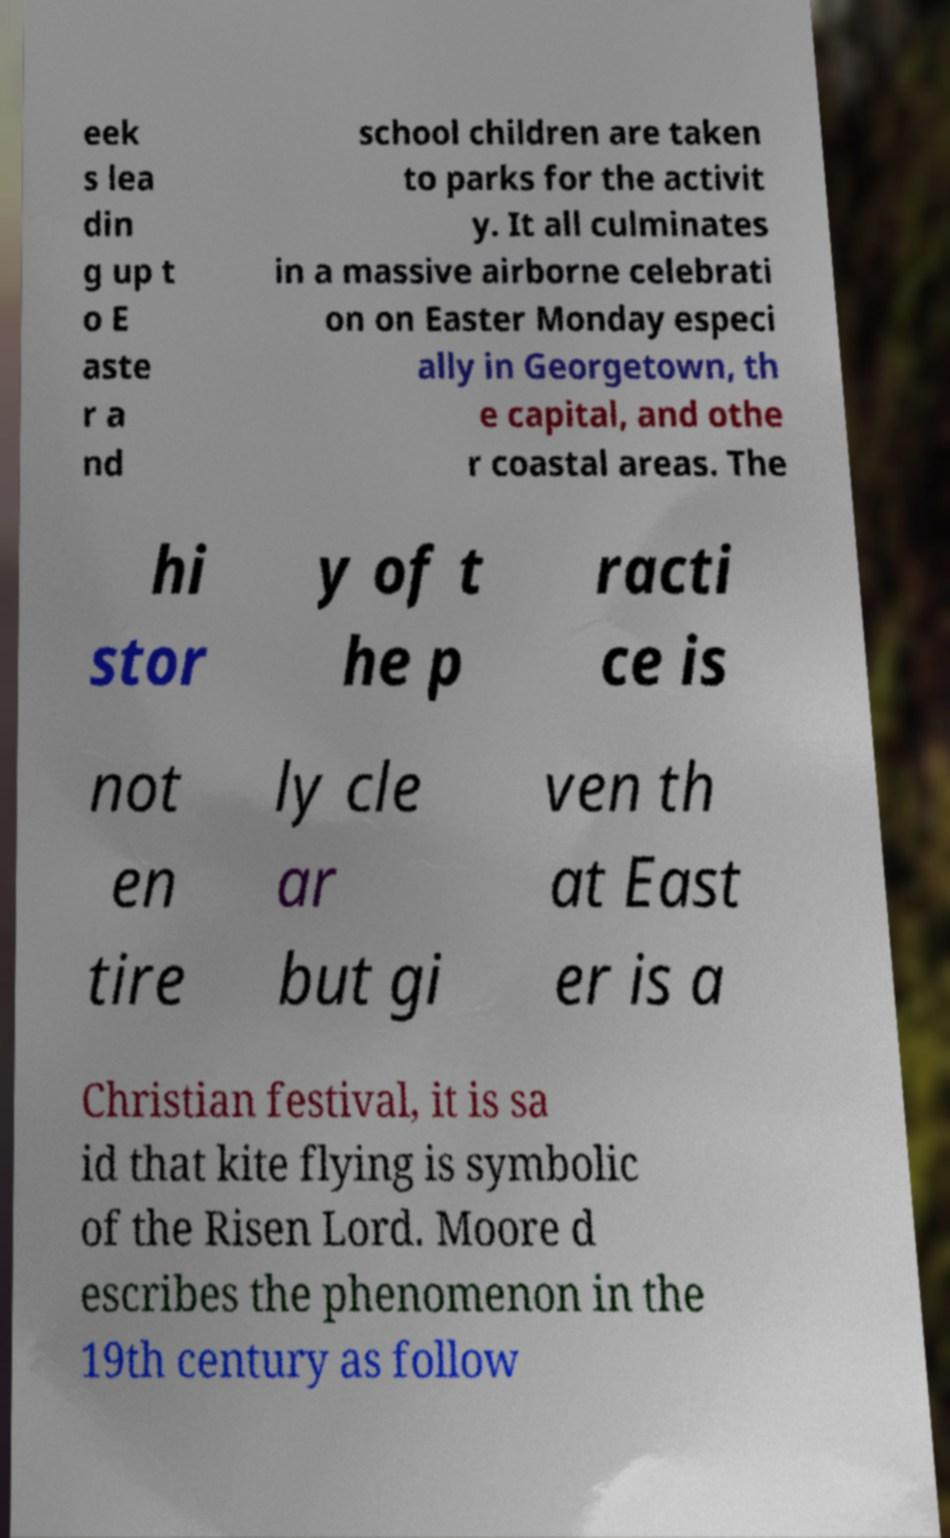There's text embedded in this image that I need extracted. Can you transcribe it verbatim? eek s lea din g up t o E aste r a nd school children are taken to parks for the activit y. It all culminates in a massive airborne celebrati on on Easter Monday especi ally in Georgetown, th e capital, and othe r coastal areas. The hi stor y of t he p racti ce is not en tire ly cle ar but gi ven th at East er is a Christian festival, it is sa id that kite flying is symbolic of the Risen Lord. Moore d escribes the phenomenon in the 19th century as follow 